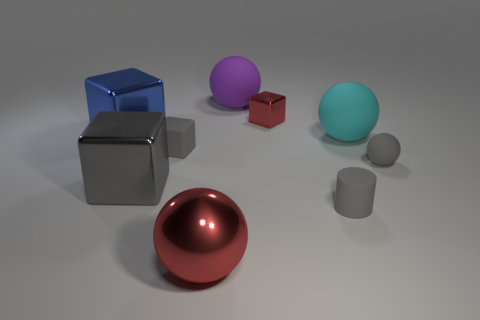Subtract 1 balls. How many balls are left? 3 Add 1 red balls. How many objects exist? 10 Subtract all spheres. How many objects are left? 5 Add 5 tiny cylinders. How many tiny cylinders exist? 6 Subtract 1 red balls. How many objects are left? 8 Subtract all tiny balls. Subtract all gray matte cylinders. How many objects are left? 7 Add 4 purple objects. How many purple objects are left? 5 